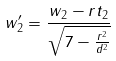<formula> <loc_0><loc_0><loc_500><loc_500>w _ { 2 } ^ { \prime } = \frac { w _ { 2 } - r t _ { 2 } } { \sqrt { 7 - \frac { r ^ { 2 } } { d ^ { 2 } } } }</formula> 